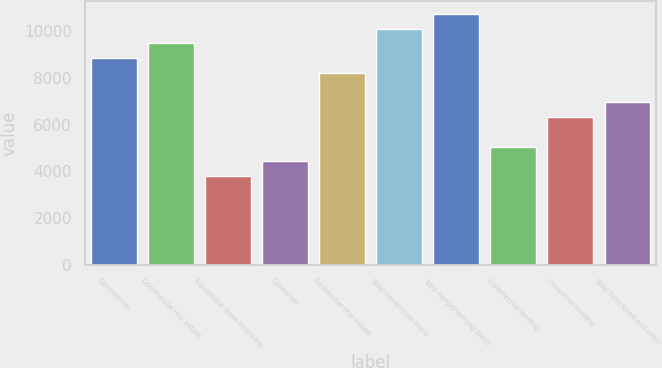Convert chart. <chart><loc_0><loc_0><loc_500><loc_500><bar_chart><fcel>Commercial<fcel>Commercial real estate<fcel>Equipment lease financing<fcel>Consumer<fcel>Residential real estate<fcel>Total nonaccrual loans<fcel>Total nonperforming loans<fcel>Commercial lending<fcel>Consumer lending<fcel>Total foreclosed and other<nl><fcel>8842.16<fcel>9473.7<fcel>3789.84<fcel>4421.38<fcel>8210.62<fcel>10105.2<fcel>10736.8<fcel>5052.92<fcel>6316<fcel>6947.54<nl></chart> 